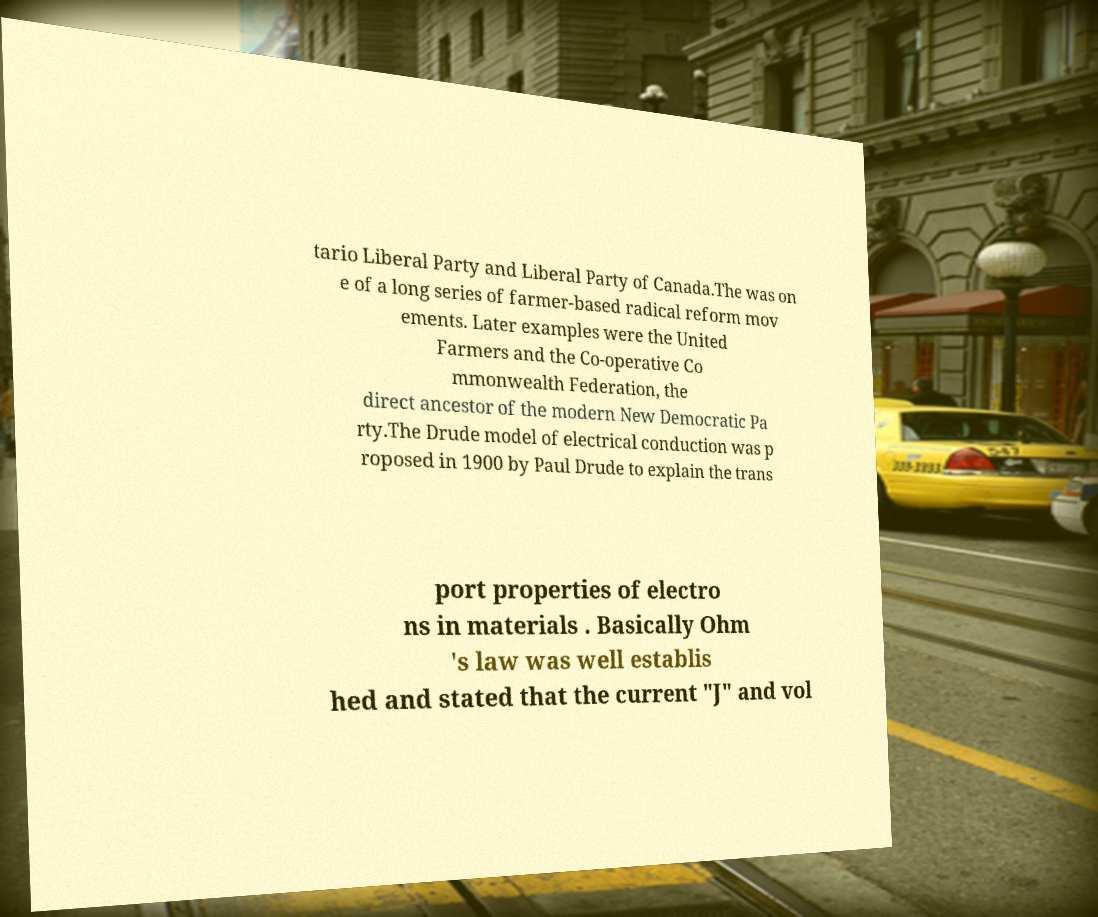Can you read and provide the text displayed in the image?This photo seems to have some interesting text. Can you extract and type it out for me? tario Liberal Party and Liberal Party of Canada.The was on e of a long series of farmer-based radical reform mov ements. Later examples were the United Farmers and the Co-operative Co mmonwealth Federation, the direct ancestor of the modern New Democratic Pa rty.The Drude model of electrical conduction was p roposed in 1900 by Paul Drude to explain the trans port properties of electro ns in materials . Basically Ohm 's law was well establis hed and stated that the current "J" and vol 